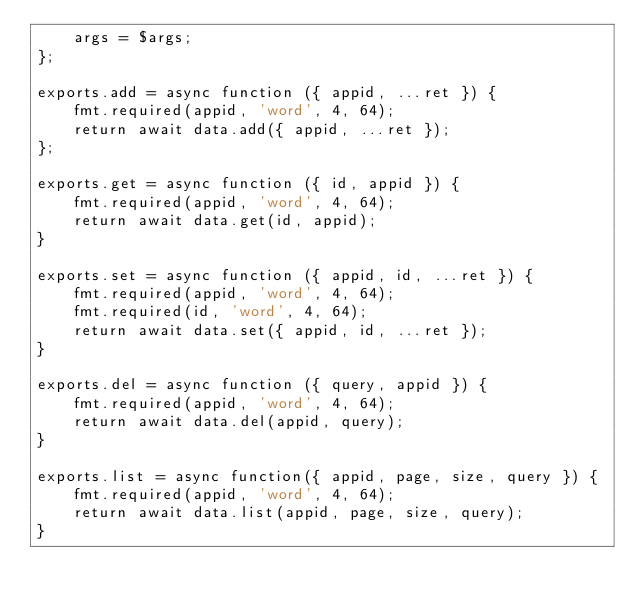Convert code to text. <code><loc_0><loc_0><loc_500><loc_500><_JavaScript_>    args = $args;
};

exports.add = async function ({ appid, ...ret }) {
    fmt.required(appid, 'word', 4, 64);
    return await data.add({ appid, ...ret });
};

exports.get = async function ({ id, appid }) {
    fmt.required(appid, 'word', 4, 64);
    return await data.get(id, appid);
}

exports.set = async function ({ appid, id, ...ret }) {
    fmt.required(appid, 'word', 4, 64);
    fmt.required(id, 'word', 4, 64);
    return await data.set({ appid, id, ...ret });
}

exports.del = async function ({ query, appid }) {
    fmt.required(appid, 'word', 4, 64);
    return await data.del(appid, query);
}

exports.list = async function({ appid, page, size, query }) {
    fmt.required(appid, 'word', 4, 64);
    return await data.list(appid, page, size, query);
}</code> 